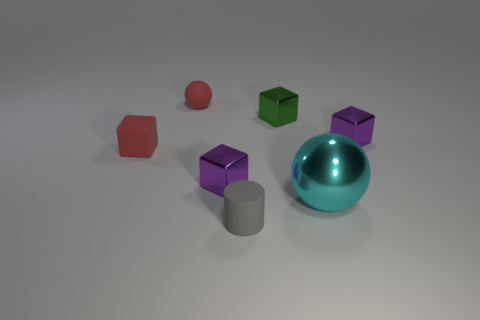Are there an equal number of green shiny cubes that are right of the gray object and rubber balls behind the tiny matte sphere?
Make the answer very short. No. Is the purple object that is behind the red matte cube made of the same material as the small red sphere?
Your response must be concise. No. What is the color of the small rubber thing that is both right of the red matte block and behind the big ball?
Your answer should be very brief. Red. There is a red matte object that is right of the red matte block; how many tiny gray objects are in front of it?
Provide a succinct answer. 1. There is another object that is the same shape as the cyan shiny thing; what is it made of?
Offer a very short reply. Rubber. The large metallic object is what color?
Make the answer very short. Cyan. How many things are green shiny blocks or big metal spheres?
Keep it short and to the point. 2. There is a purple object that is in front of the thing left of the small ball; what shape is it?
Offer a terse response. Cube. How many other things are there of the same material as the red sphere?
Ensure brevity in your answer.  2. Are the green object and the small purple cube that is on the right side of the gray matte cylinder made of the same material?
Keep it short and to the point. Yes. 